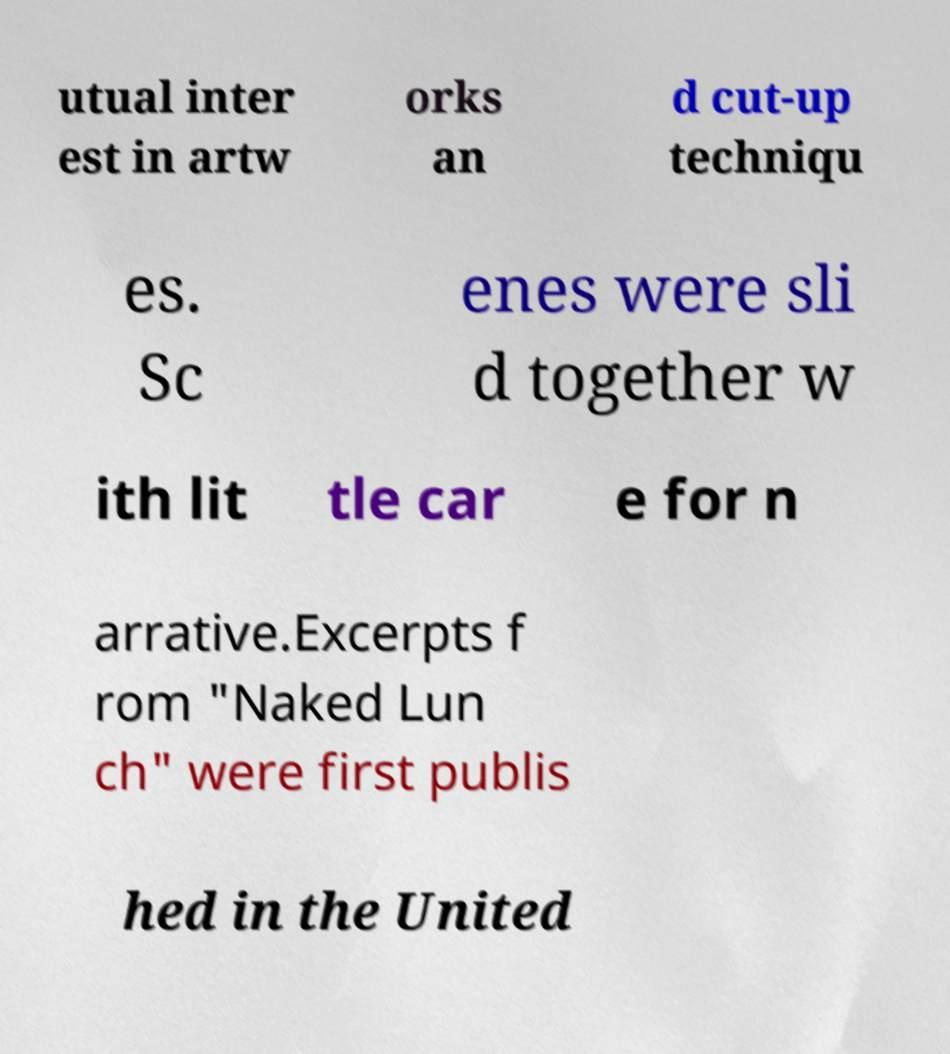I need the written content from this picture converted into text. Can you do that? utual inter est in artw orks an d cut-up techniqu es. Sc enes were sli d together w ith lit tle car e for n arrative.Excerpts f rom "Naked Lun ch" were first publis hed in the United 